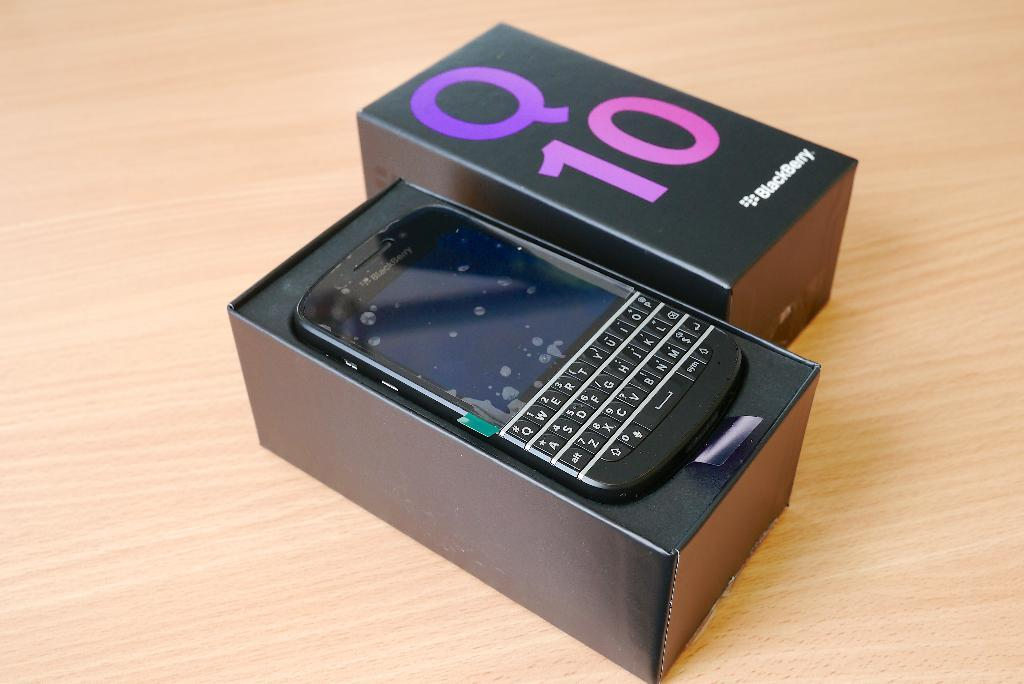<image>
Give a short and clear explanation of the subsequent image. a box with Q 10 written on it and a turned off blackberry 